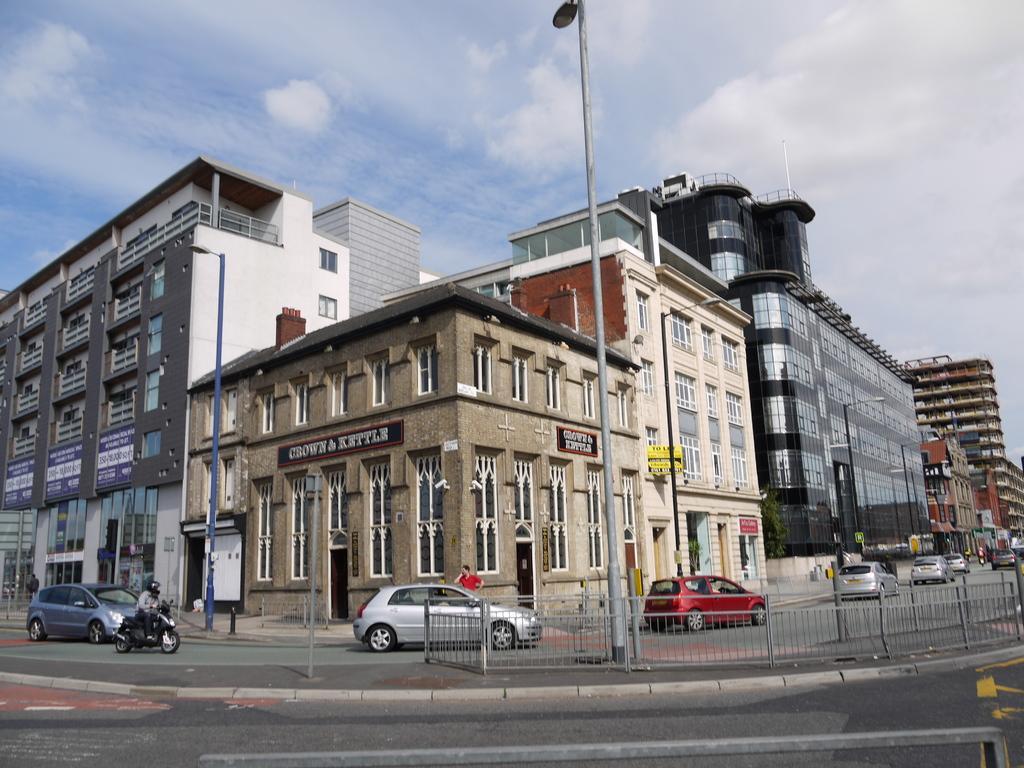Can you describe this image briefly? In this image there is a road at the bottom. There is sky at the top. There are buildings, people, vehicles, poles with lights in the foreground. 